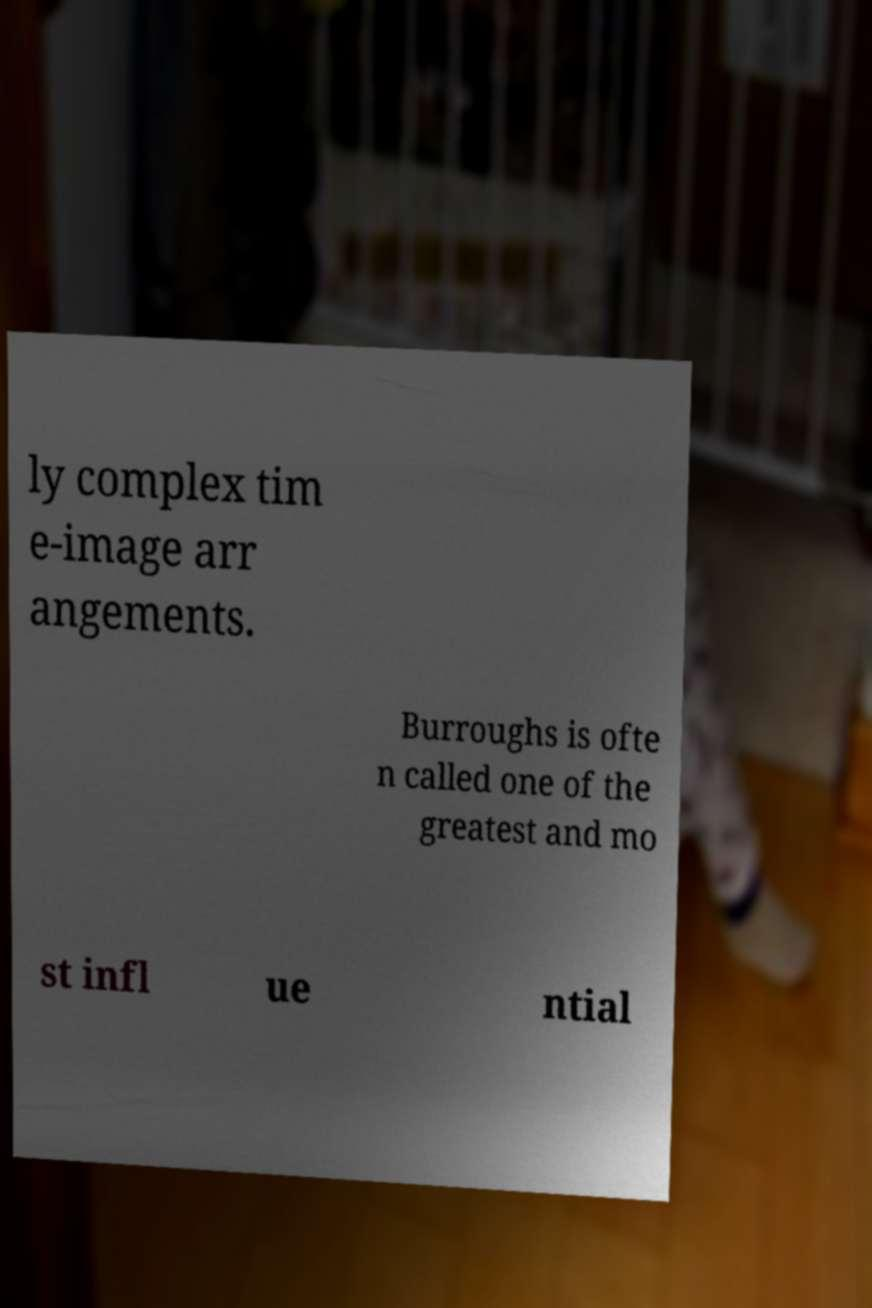Can you read and provide the text displayed in the image?This photo seems to have some interesting text. Can you extract and type it out for me? ly complex tim e-image arr angements. Burroughs is ofte n called one of the greatest and mo st infl ue ntial 